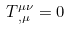<formula> <loc_0><loc_0><loc_500><loc_500>T ^ { \mu \nu } _ { \, , \mu } = 0</formula> 